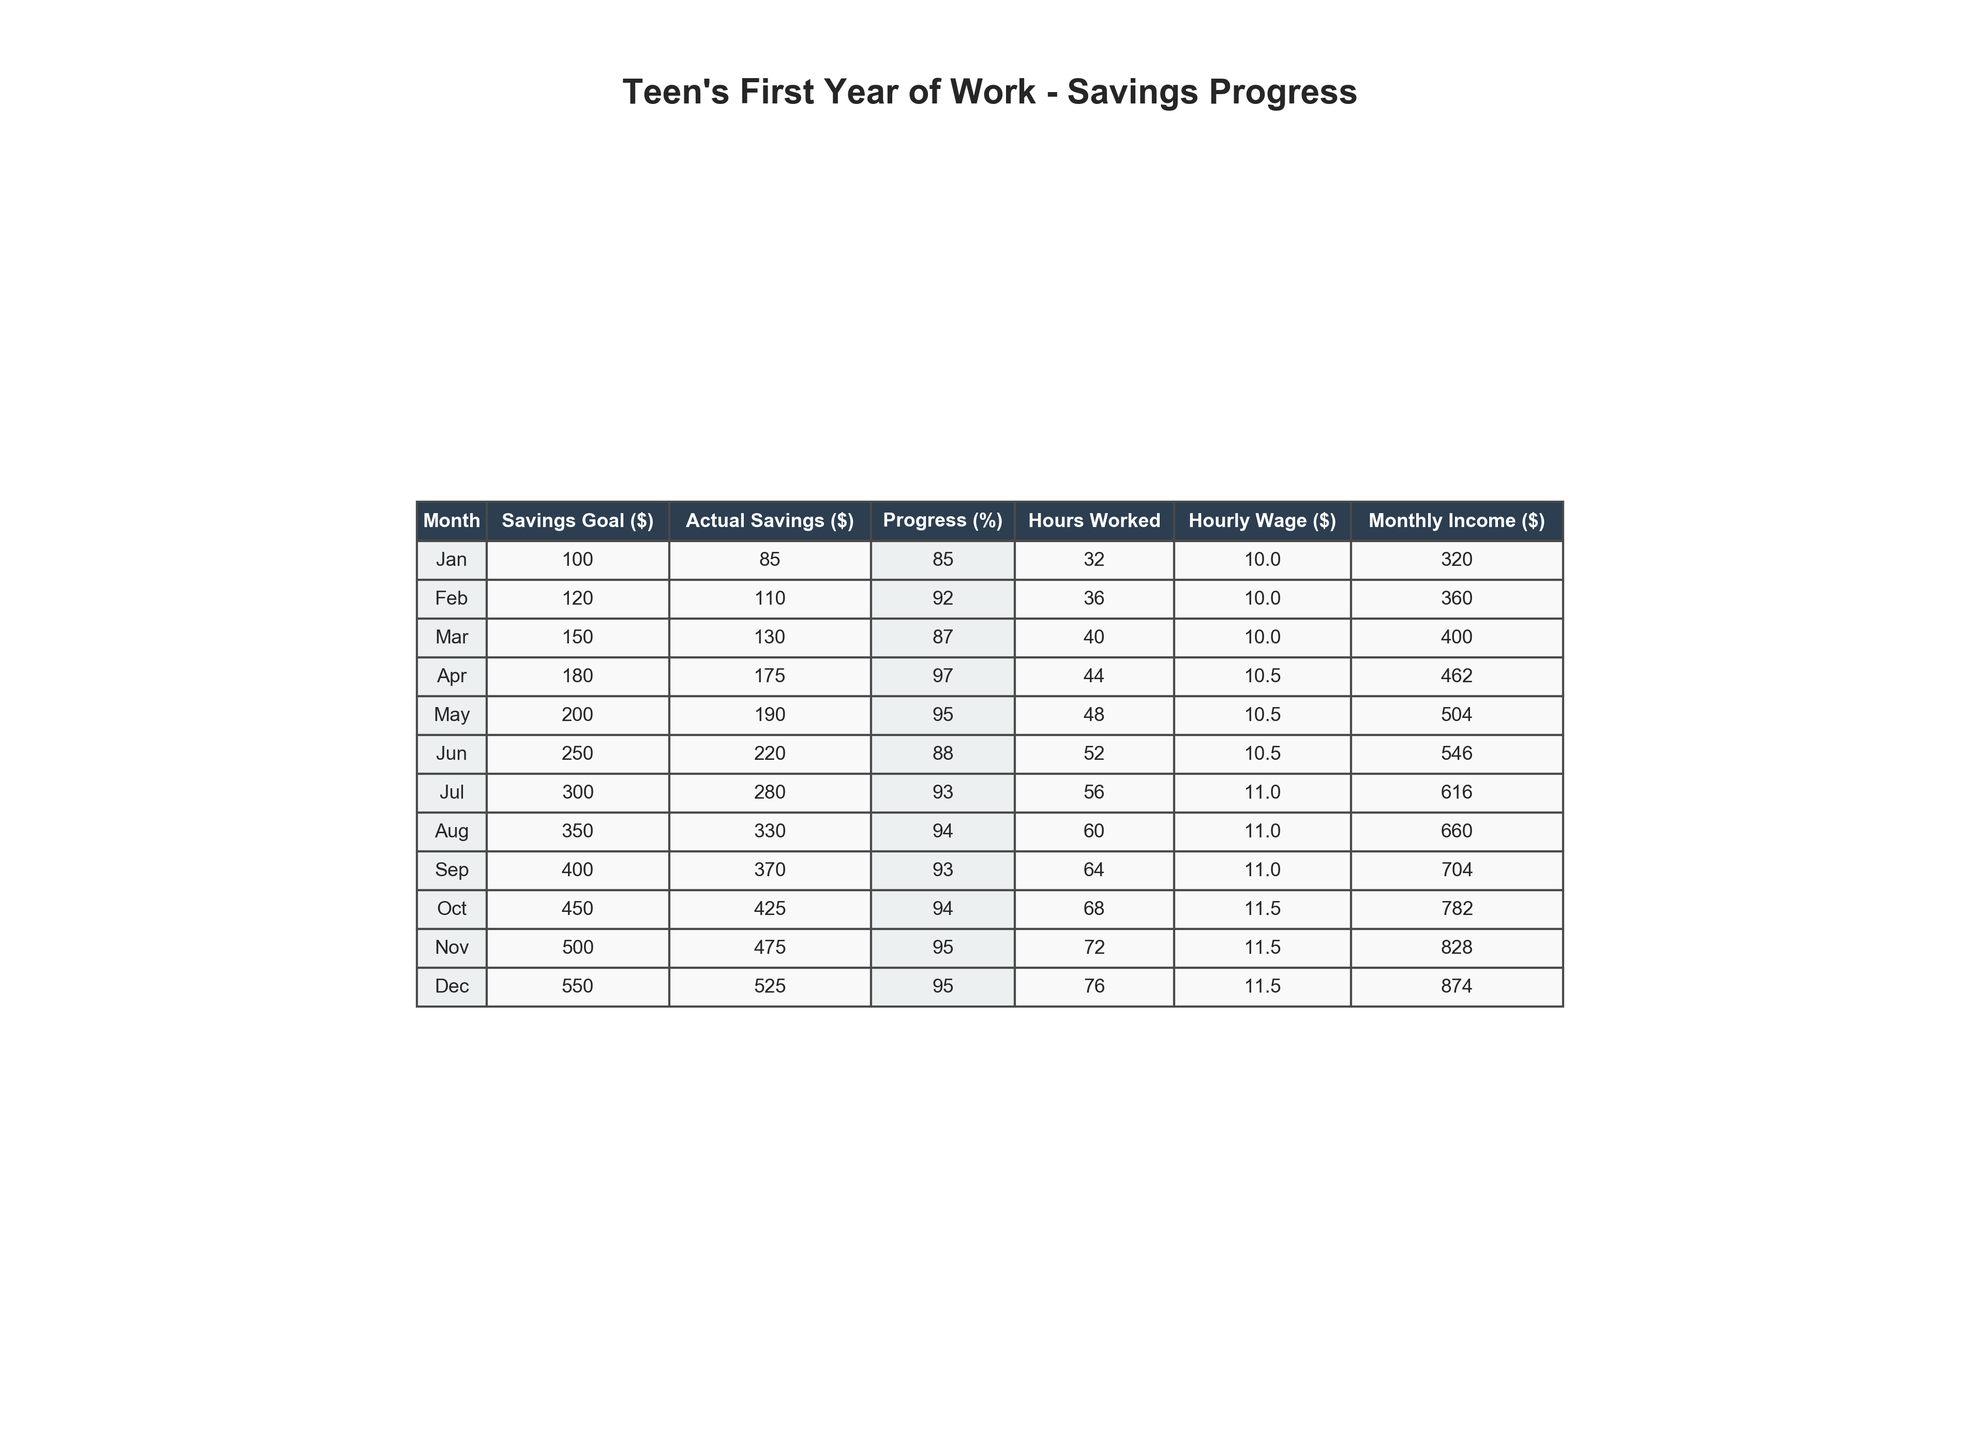What was the actual savings in June? The table directly shows the actual savings for June as $220.
Answer: 220 How many hours were worked in December? Referring to the table, the hours worked in December is listed as 76 hours.
Answer: 76 What is the total savings goal from January to March? From the table, the savings goals for January ($100), February ($120), and March ($150) add up to $370.
Answer: 370 What percentage progress was made in November? The table indicates that the progress in November is 95%.
Answer: 95 Was the actual savings in October higher than the savings goal? In October, the actual savings was $425 and the savings goal was $450. Since $425 is less than $450, the answer is No.
Answer: No What is the average monthly income over the year? The total monthly income is calculated by summing all monthly incomes: (320 + 360 + 400 + 462 + 504 + 546 + 616 + 660 + 704 + 782 + 828 + 874) = 6,522, and dividing by 12 months gives an average of $543.50.
Answer: 543.50 Which month had the least amount of unexpected expenses? By reviewing the table, January has the least unexpected expenses at $20.
Answer: 20 If the unexpected expenses are excluded, what is the total actual savings by the end of the year? First, sum the actual savings: (85 + 110 + 130 + 175 + 190 + 220 + 280 + 330 + 370 + 425 + 475 + 525) = 2,265, which gives the total actual savings without adjusting for expenses.
Answer: 2265 What was the highest percentage of progress made in any month? The highest percentage of progress is 97%, as seen in April.
Answer: 97 How much did the hourly wage increase from January to December? The hourly wage increased from $10 in January to $11.50 in December, which is an increase of $1.50.
Answer: 1.50 